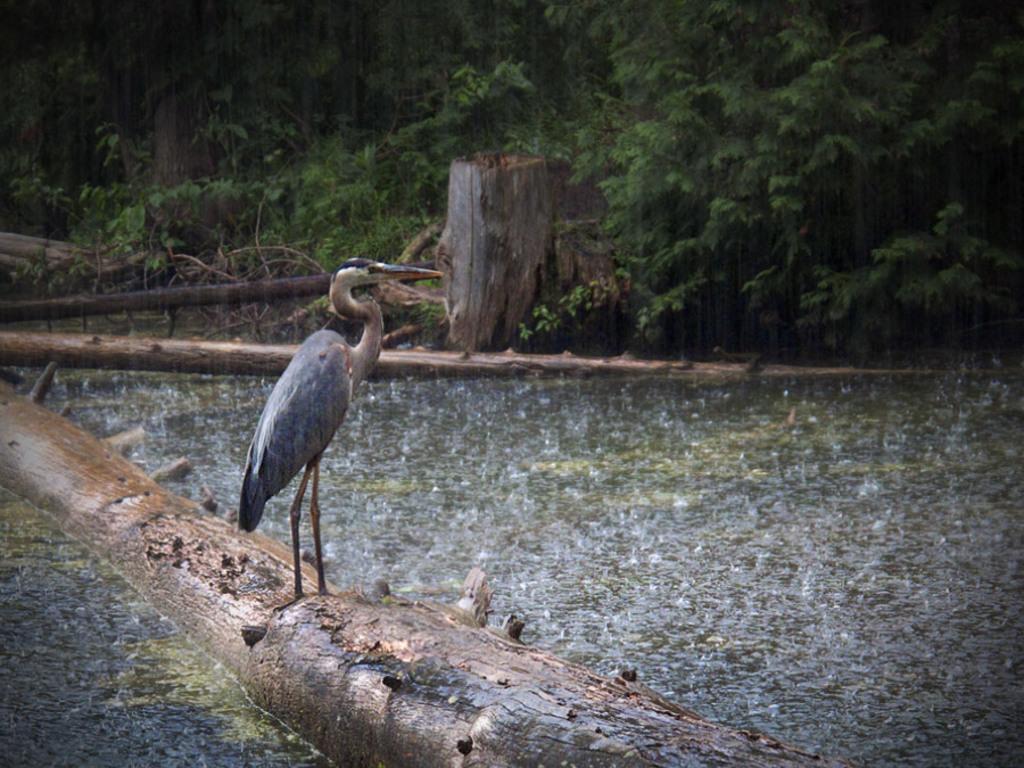Can you describe this image briefly? In the foreground of this picture, there is a crane standing on the trunk which is in water. In the background, we see trees, and a trunk fell down to the ground. 